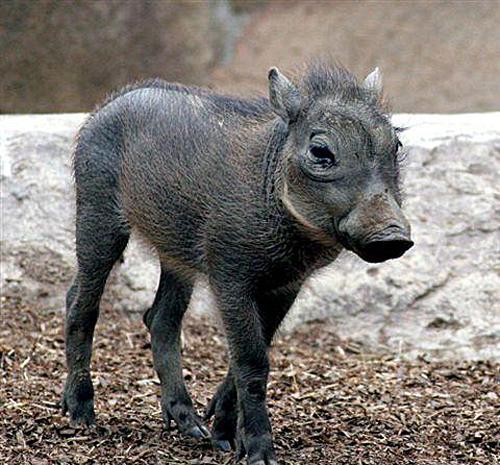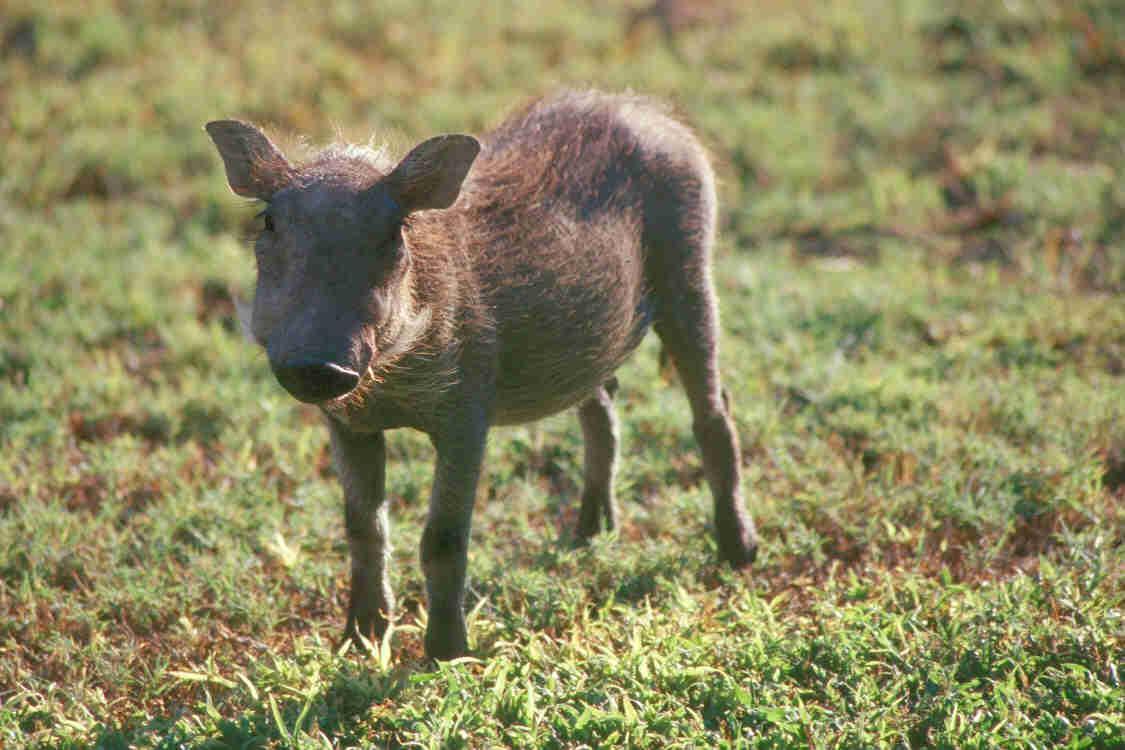The first image is the image on the left, the second image is the image on the right. Considering the images on both sides, is "One of the animals is lying down on the ground." valid? Answer yes or no. No. The first image is the image on the left, the second image is the image on the right. Evaluate the accuracy of this statement regarding the images: "Left and right images contain the same number of warthogs, and the combined images contain at least four warthogs.". Is it true? Answer yes or no. No. 